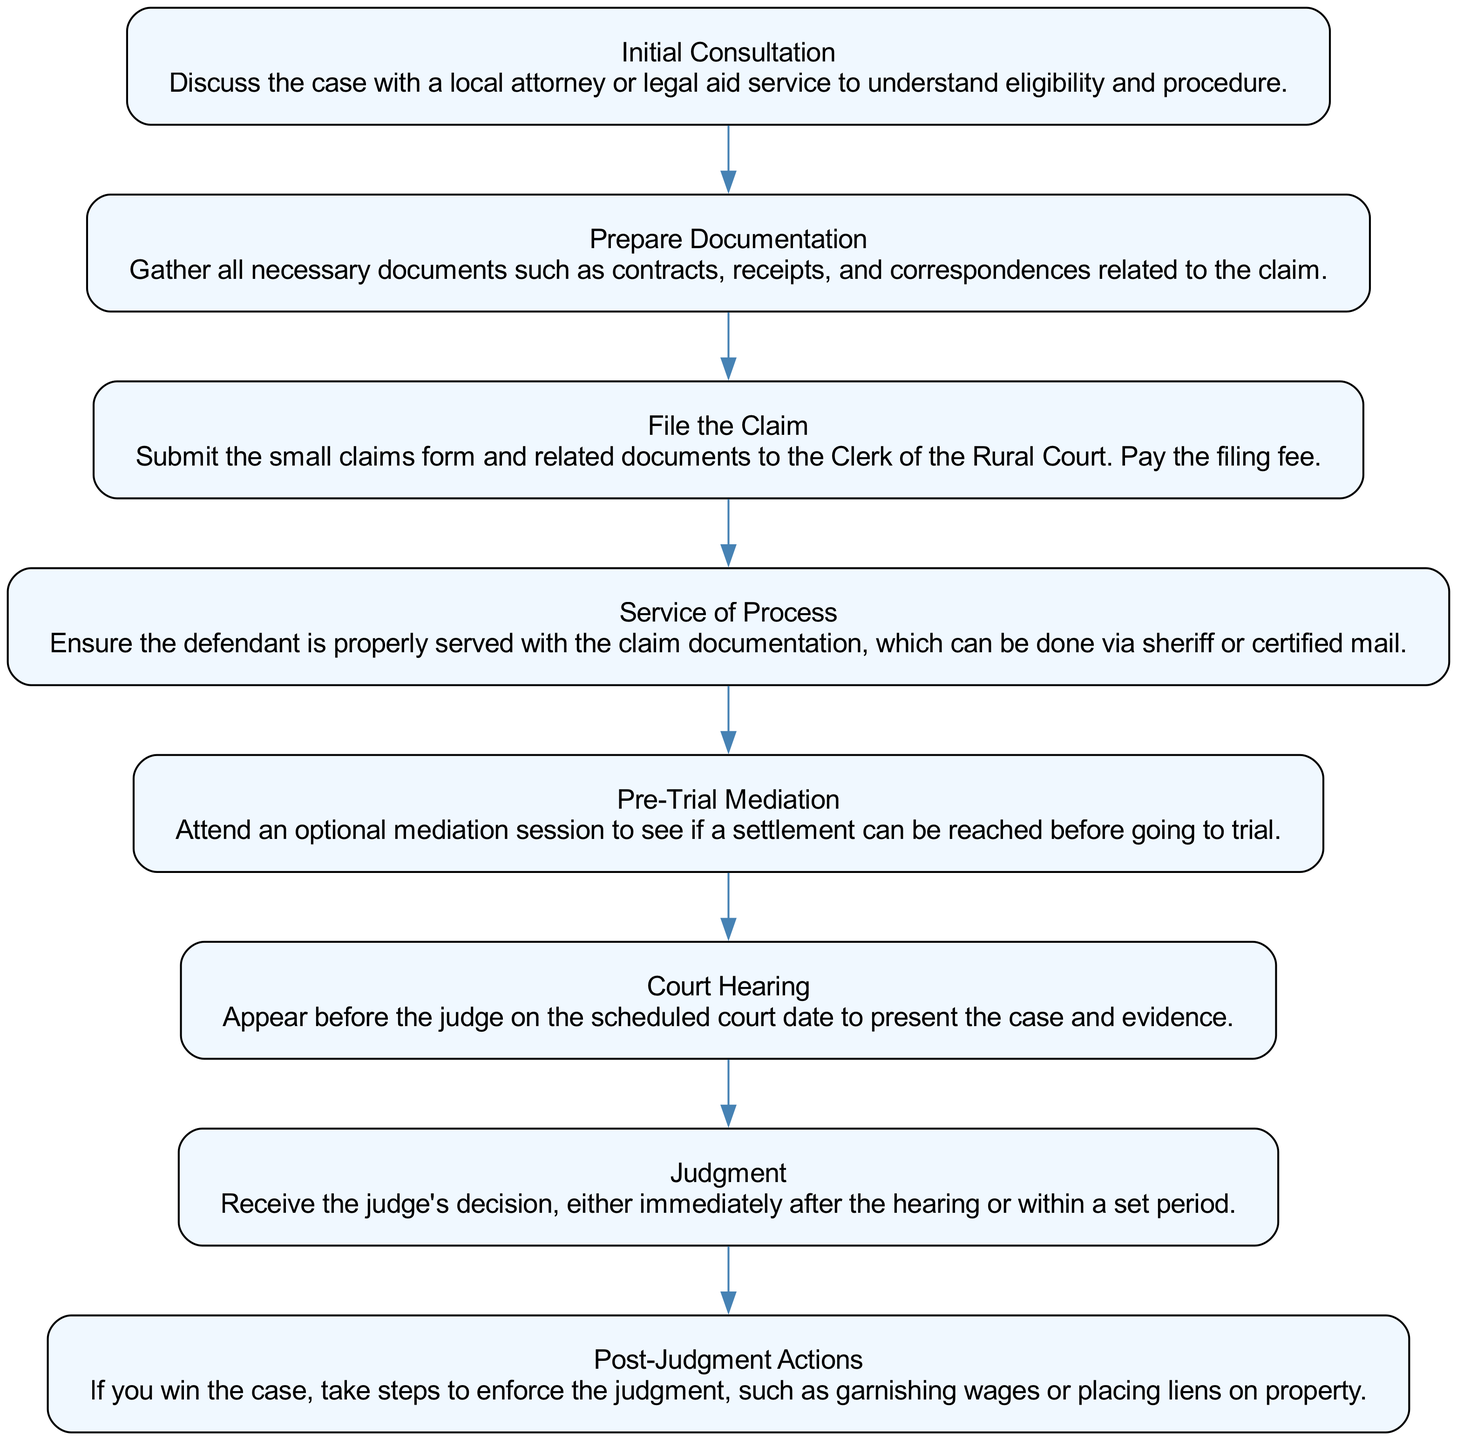What is the first step in the workflow? The first step in the workflow is "Initial Consultation," which indicates that a discussion with a local attorney or legal aid service is necessary to understand eligibility and procedure before proceeding further.
Answer: Initial Consultation How many steps are there in the workflow? By counting each step from the diagram, it is clear that there are a total of eight steps outlined in the workflow for filing a small claims case in rural courts.
Answer: 8 Which step comes after "File the Claim"? Looking at the flow of the diagram, "Service of Process" follows "File the Claim," indicating the next action that must be taken after filing the claim.
Answer: Service of Process What action follows "Court Hearing"? According to the sequence in the diagram, the action that follows "Court Hearing" is "Judgment," which suggests that after presenting the case in court, a decision will be rendered by the judge.
Answer: Judgment What is the last action mentioned in the workflow? The last action listed in the workflow is "Post-Judgment Actions," which indicates the steps to enforce the judgment after receiving a decision.
Answer: Post-Judgment Actions What happens if mediation is not successful? Although the diagram does not specify outcomes if mediation fails, after "Pre-Trial Mediation," the next step remains "Court Hearing," implying that if mediation is not successful, the case proceeds to court.
Answer: Court Hearing Which step requires the defendant to be served? The step that requires the defendant to be served is "Service of Process," as it involves ensuring that the defendant receives the claim documentation.
Answer: Service of Process Which step involves gathering documents? "Prepare Documentation" is the step that involves gathering necessary documents such as contracts, receipts, and correspondences related to the claim.
Answer: Prepare Documentation What is the purpose of "Pre-Trial Mediation"? The primary purpose of "Pre-Trial Mediation" is to allow the parties involved to attend an optional session to potentially reach a settlement before proceeding to trial.
Answer: Optional mediation session 